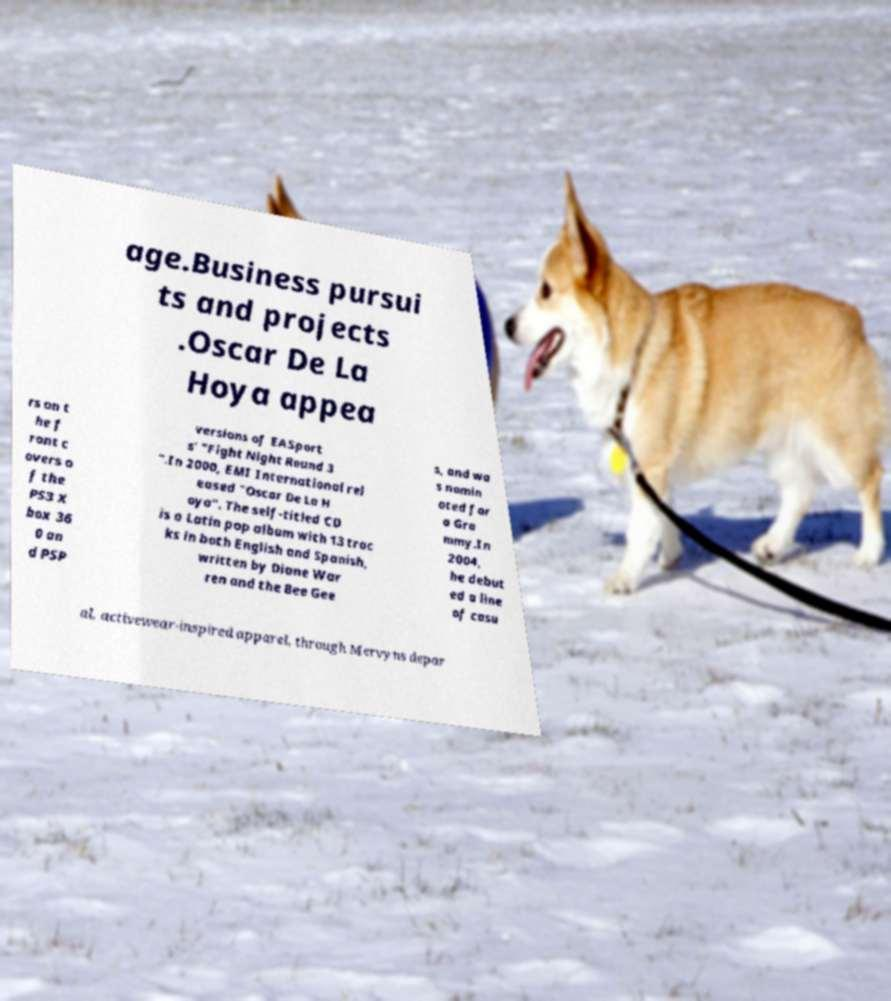There's text embedded in this image that I need extracted. Can you transcribe it verbatim? age.Business pursui ts and projects .Oscar De La Hoya appea rs on t he f ront c overs o f the PS3 X box 36 0 an d PSP versions of EASport s' "Fight Night Round 3 ".In 2000, EMI International rel eased "Oscar De La H oya". The self-titled CD is a Latin pop album with 13 trac ks in both English and Spanish, written by Diane War ren and the Bee Gee s, and wa s nomin ated for a Gra mmy.In 2004, he debut ed a line of casu al, activewear-inspired apparel, through Mervyns depar 